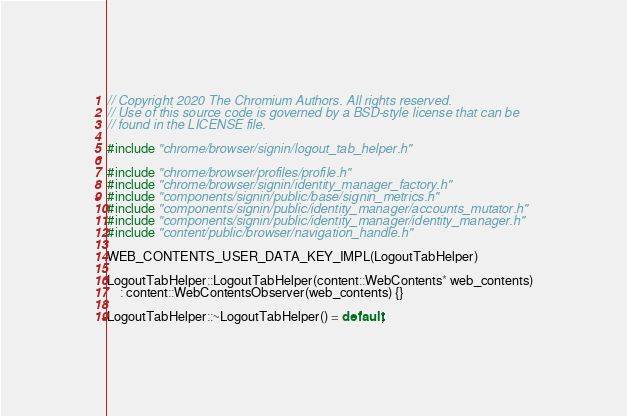<code> <loc_0><loc_0><loc_500><loc_500><_C++_>// Copyright 2020 The Chromium Authors. All rights reserved.
// Use of this source code is governed by a BSD-style license that can be
// found in the LICENSE file.

#include "chrome/browser/signin/logout_tab_helper.h"

#include "chrome/browser/profiles/profile.h"
#include "chrome/browser/signin/identity_manager_factory.h"
#include "components/signin/public/base/signin_metrics.h"
#include "components/signin/public/identity_manager/accounts_mutator.h"
#include "components/signin/public/identity_manager/identity_manager.h"
#include "content/public/browser/navigation_handle.h"

WEB_CONTENTS_USER_DATA_KEY_IMPL(LogoutTabHelper)

LogoutTabHelper::LogoutTabHelper(content::WebContents* web_contents)
    : content::WebContentsObserver(web_contents) {}

LogoutTabHelper::~LogoutTabHelper() = default;
</code> 